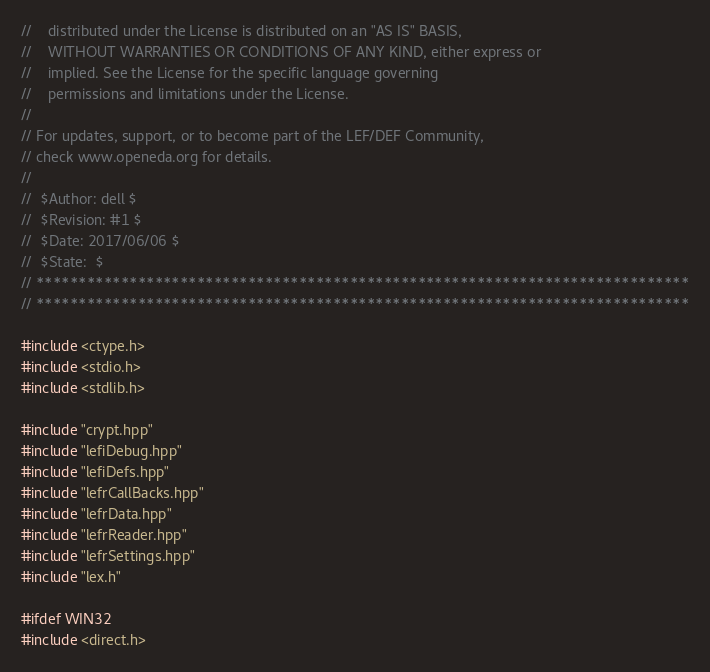<code> <loc_0><loc_0><loc_500><loc_500><_C++_>//    distributed under the License is distributed on an "AS IS" BASIS,
//    WITHOUT WARRANTIES OR CONDITIONS OF ANY KIND, either express or
//    implied. See the License for the specific language governing
//    permissions and limitations under the License.
//
// For updates, support, or to become part of the LEF/DEF Community,
// check www.openeda.org for details.
//
//  $Author: dell $
//  $Revision: #1 $
//  $Date: 2017/06/06 $
//  $State:  $
// *****************************************************************************
// *****************************************************************************

#include <ctype.h>
#include <stdio.h>
#include <stdlib.h>

#include "crypt.hpp"
#include "lefiDebug.hpp"
#include "lefiDefs.hpp"
#include "lefrCallBacks.hpp"
#include "lefrData.hpp"
#include "lefrReader.hpp"
#include "lefrSettings.hpp"
#include "lex.h"

#ifdef WIN32
#include <direct.h></code> 